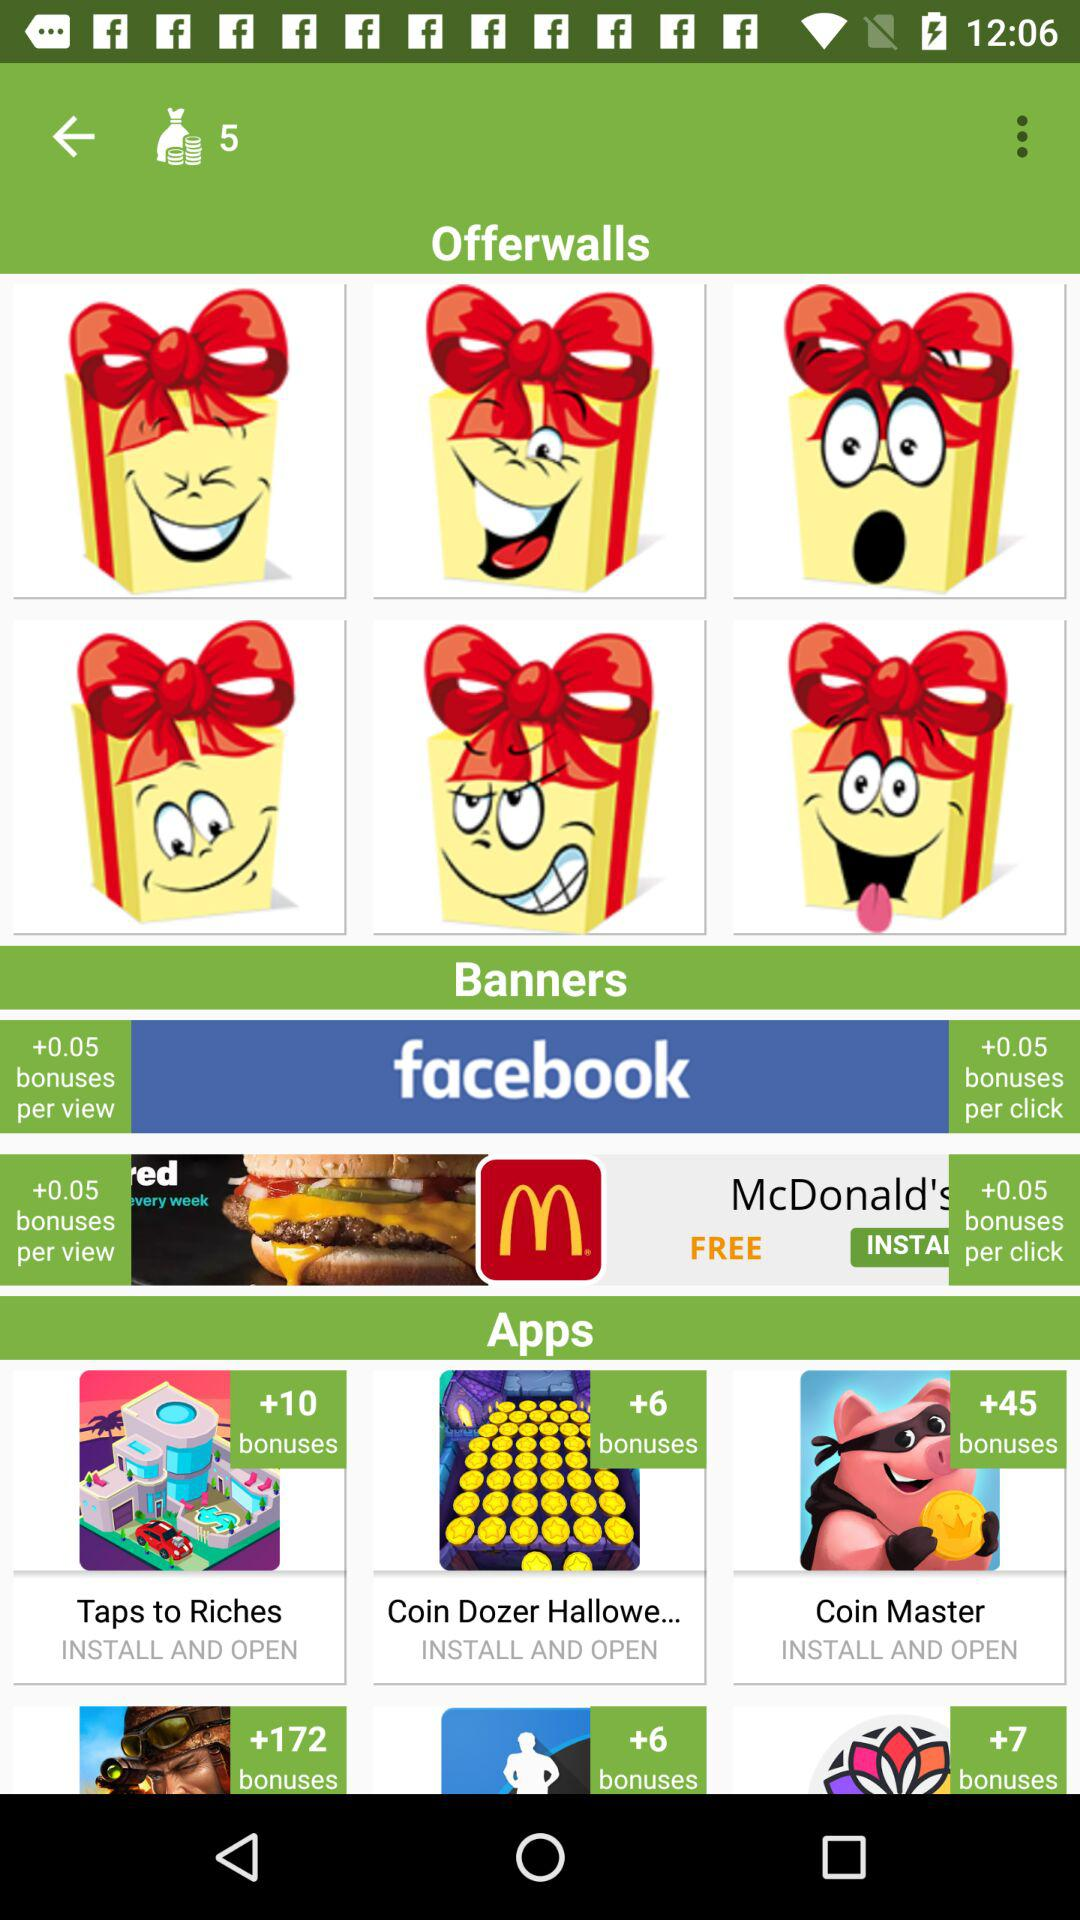How many more bonuses are offered for installing and opening Coin Master than Taps to Riches?
Answer the question using a single word or phrase. 35 